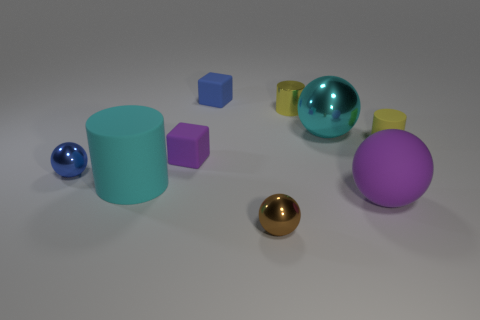Are there the same number of small yellow rubber things that are in front of the small yellow rubber object and yellow matte cylinders that are behind the metal cylinder?
Your response must be concise. Yes. There is a blue metal object; is its size the same as the cyan ball that is behind the blue metal thing?
Make the answer very short. No. Are there more small cubes that are in front of the cyan ball than small red metal spheres?
Keep it short and to the point. Yes. What number of blue matte cubes have the same size as the blue ball?
Provide a short and direct response. 1. There is a purple matte thing to the left of the blue matte cube; does it have the same size as the shiny object in front of the large cyan cylinder?
Offer a very short reply. Yes. Is the number of big cyan rubber cylinders on the right side of the big cyan rubber cylinder greater than the number of purple things on the right side of the small purple thing?
Keep it short and to the point. No. How many large purple shiny things have the same shape as the small yellow metallic object?
Your answer should be very brief. 0. What is the material of the purple thing that is the same size as the yellow matte thing?
Provide a short and direct response. Rubber. Are there any other purple balls that have the same material as the purple ball?
Make the answer very short. No. Are there fewer purple matte cubes left of the big purple rubber ball than big red spheres?
Keep it short and to the point. No. 